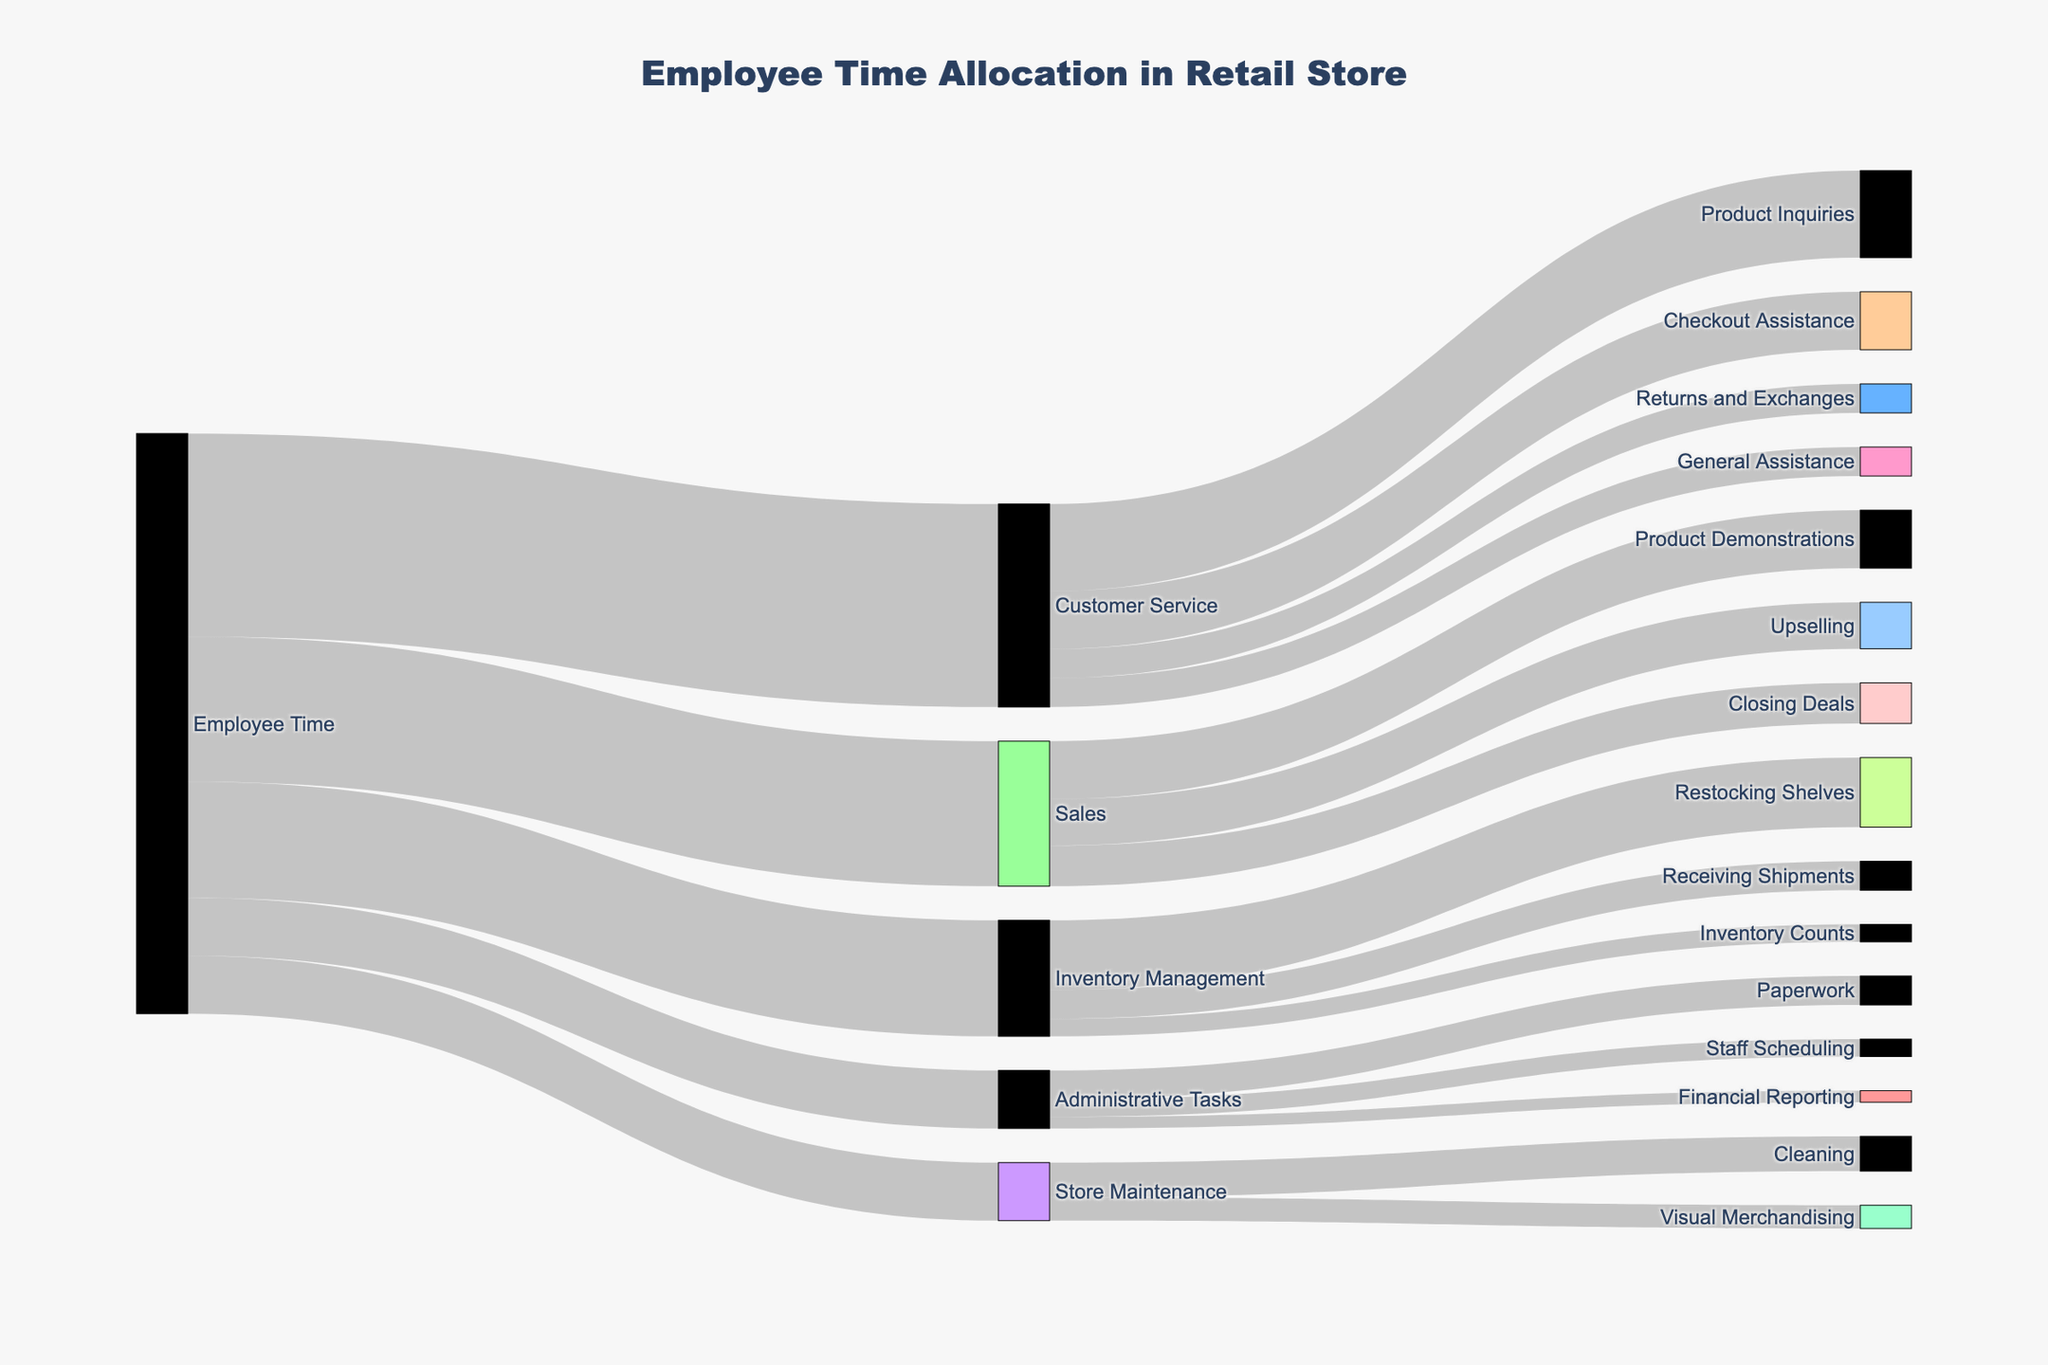what is the most time-consuming task for employees? By reviewing the connections in the Sankey diagram starting from "Employee Time," it's evident which task receives the greatest allocation. The task with the largest flow value is the most time-consuming.
Answer: Customer Service How many tasks are categorized under Customer Service? Observe the flows extending from "Customer Service" to determine how many distinct tasks are included under it.
Answer: 4 Which is greater: time spent on Inventory Management or time spent on Administrative Tasks? Compare the flow values connected to "Inventory Management" and "Administrative Tasks" from "Employee Time" to see which is larger.
Answer: Inventory Management What is the combined time spent on Cleaning and Restocking Shelves? Add the values for "Cleaning" and "Restocking Shelves" from the two respective sources "Store Maintenance" and "Inventory Management" to find the total.
Answer: 18 How does the time spent on Sales compare to the time spent on Inventory Management? Examine the values of the links from "Employee Time" to "Sales" and "Inventory Management" to compare which one is higher.
Answer: Sales is higher Which specific task within Customer Service takes up the most time? Look at the values connected to each target under "Customer Service" and identify the one with the highest value.
Answer: Product Inquiries What percentage of time is allocated to Sales activities out of the total employee time? Sum the total value of all employee time allocations and then calculate the percentage of the total that is due to Sales. Total allocation is 100 (35+20+25+10+10), with Sales being 25. Therefore, (25/100) * 100% = 25%.
Answer: 25% How do Paperwork and Checkout Assistance compare in terms of time allocation? Observe the values linked to "Paperwork" under "Administrative Tasks" and "Checkout Assistance" under "Customer Service" to compare their time allocation.
Answer: Checkout Assistance has more time Calculate the total time spent on tasks within Administrative Tasks. Add up the individual values for all tasks under "Administrative Tasks" by looking at their respective flows.
Answer: 10 What is the least time-consuming task under Inventory Management? Observe the tasks under "Inventory Management" and identify the one with the smallest value.
Answer: Inventory Counts 